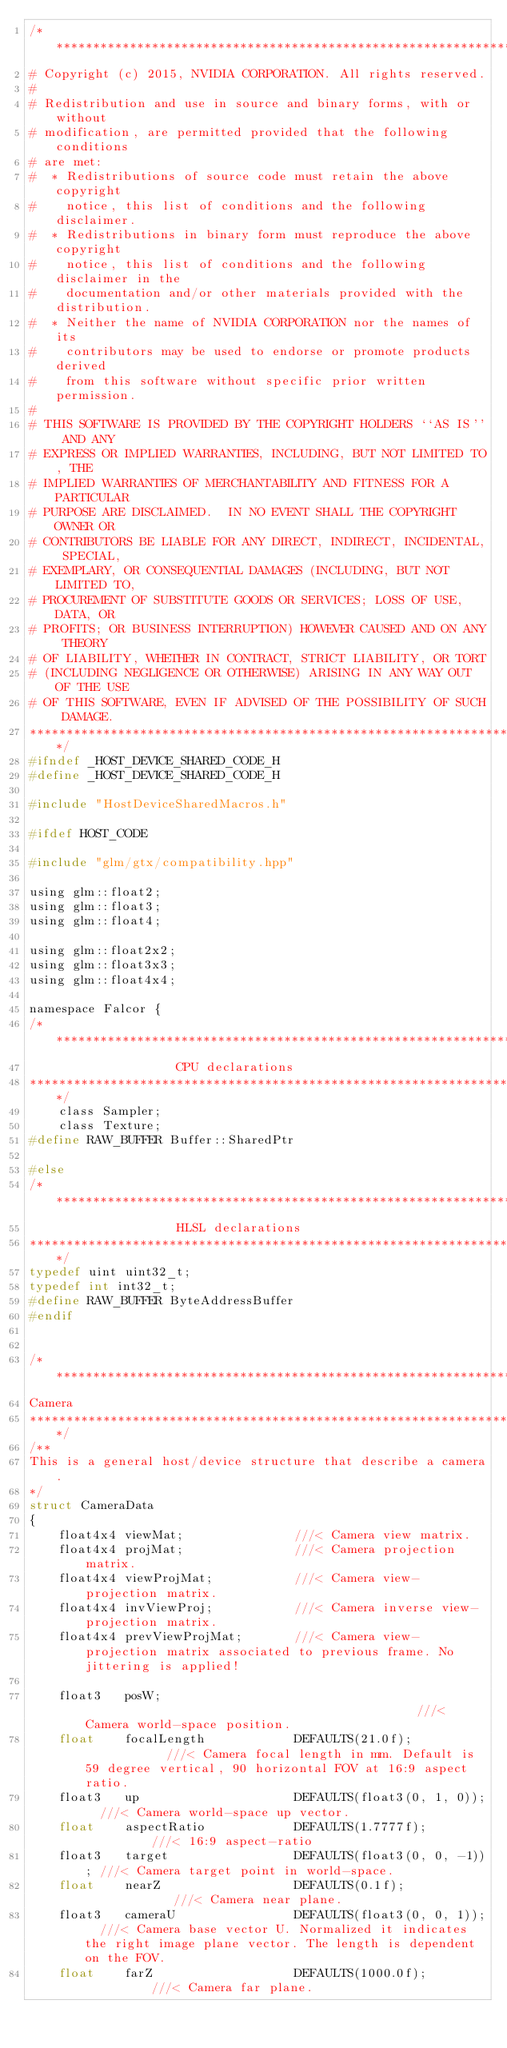<code> <loc_0><loc_0><loc_500><loc_500><_C_>/***************************************************************************
# Copyright (c) 2015, NVIDIA CORPORATION. All rights reserved.
#
# Redistribution and use in source and binary forms, with or without
# modification, are permitted provided that the following conditions
# are met:
#  * Redistributions of source code must retain the above copyright
#    notice, this list of conditions and the following disclaimer.
#  * Redistributions in binary form must reproduce the above copyright
#    notice, this list of conditions and the following disclaimer in the
#    documentation and/or other materials provided with the distribution.
#  * Neither the name of NVIDIA CORPORATION nor the names of its
#    contributors may be used to endorse or promote products derived
#    from this software without specific prior written permission.
#
# THIS SOFTWARE IS PROVIDED BY THE COPYRIGHT HOLDERS ``AS IS'' AND ANY
# EXPRESS OR IMPLIED WARRANTIES, INCLUDING, BUT NOT LIMITED TO, THE
# IMPLIED WARRANTIES OF MERCHANTABILITY AND FITNESS FOR A PARTICULAR
# PURPOSE ARE DISCLAIMED.  IN NO EVENT SHALL THE COPYRIGHT OWNER OR
# CONTRIBUTORS BE LIABLE FOR ANY DIRECT, INDIRECT, INCIDENTAL, SPECIAL,
# EXEMPLARY, OR CONSEQUENTIAL DAMAGES (INCLUDING, BUT NOT LIMITED TO,
# PROCUREMENT OF SUBSTITUTE GOODS OR SERVICES; LOSS OF USE, DATA, OR
# PROFITS; OR BUSINESS INTERRUPTION) HOWEVER CAUSED AND ON ANY THEORY
# OF LIABILITY, WHETHER IN CONTRACT, STRICT LIABILITY, OR TORT
# (INCLUDING NEGLIGENCE OR OTHERWISE) ARISING IN ANY WAY OUT OF THE USE
# OF THIS SOFTWARE, EVEN IF ADVISED OF THE POSSIBILITY OF SUCH DAMAGE.
***************************************************************************/
#ifndef _HOST_DEVICE_SHARED_CODE_H
#define _HOST_DEVICE_SHARED_CODE_H

#include "HostDeviceSharedMacros.h"

#ifdef HOST_CODE

#include "glm/gtx/compatibility.hpp"

using glm::float2;
using glm::float3;
using glm::float4;

using glm::float2x2;
using glm::float3x3;
using glm::float4x4;

namespace Falcor {
/*******************************************************************
                    CPU declarations
*******************************************************************/
    class Sampler;
    class Texture;
#define RAW_BUFFER Buffer::SharedPtr

#else
/*******************************************************************
                    HLSL declarations
*******************************************************************/
typedef uint uint32_t;
typedef int int32_t;
#define RAW_BUFFER ByteAddressBuffer
#endif


/*******************************************************************
Camera
*******************************************************************/
/**
This is a general host/device structure that describe a camera.
*/
struct CameraData
{
    float4x4 viewMat;               ///< Camera view matrix.
    float4x4 projMat;               ///< Camera projection matrix.
    float4x4 viewProjMat;           ///< Camera view-projection matrix.
    float4x4 invViewProj;           ///< Camera inverse view-projection matrix.
    float4x4 prevViewProjMat;       ///< Camera view-projection matrix associated to previous frame. No jittering is applied!

    float3   posW;                                              ///< Camera world-space position.
    float    focalLength            DEFAULTS(21.0f);            ///< Camera focal length in mm. Default is 59 degree vertical, 90 horizontal FOV at 16:9 aspect ratio.
    float3   up                     DEFAULTS(float3(0, 1, 0));  ///< Camera world-space up vector.
    float    aspectRatio            DEFAULTS(1.7777f);          ///< 16:9 aspect-ratio
    float3   target                 DEFAULTS(float3(0, 0, -1)); ///< Camera target point in world-space.
    float    nearZ                  DEFAULTS(0.1f);             ///< Camera near plane.
    float3   cameraU                DEFAULTS(float3(0, 0, 1));  ///< Camera base vector U. Normalized it indicates the right image plane vector. The length is dependent on the FOV.
    float    farZ                   DEFAULTS(1000.0f);          ///< Camera far plane.</code> 